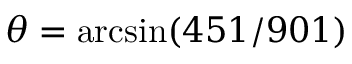Convert formula to latex. <formula><loc_0><loc_0><loc_500><loc_500>\theta = \arcsin ( 4 5 1 / 9 0 1 )</formula> 